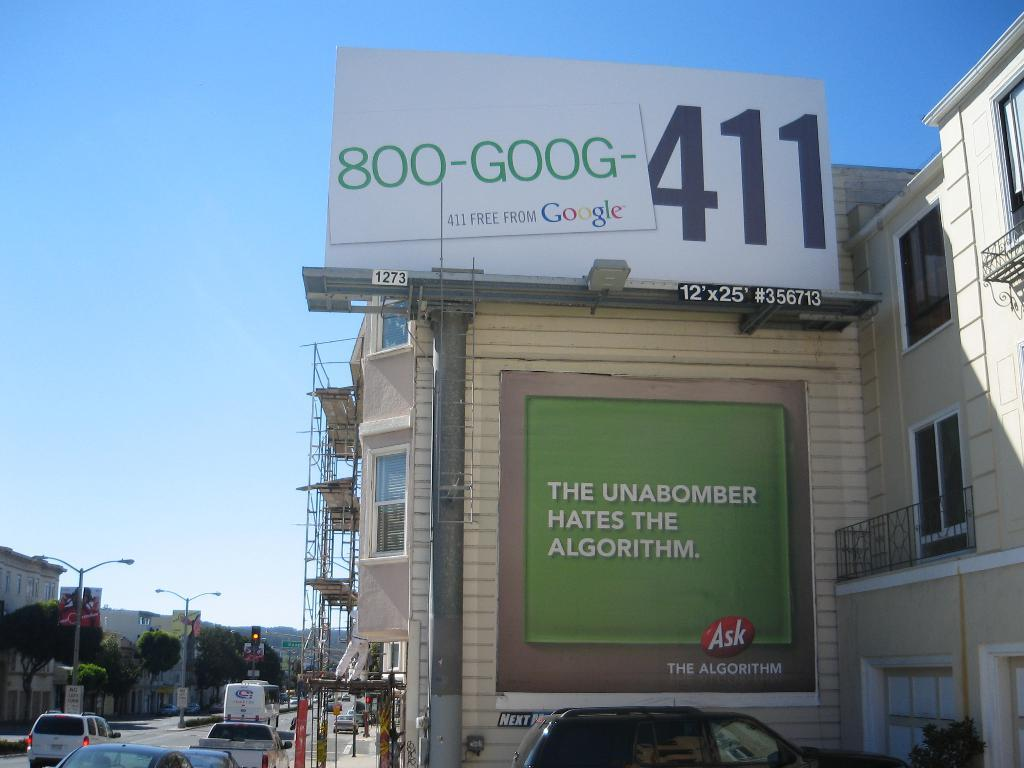<image>
Write a terse but informative summary of the picture. The side of a building has a sign about the unabomber and the algorithm. 